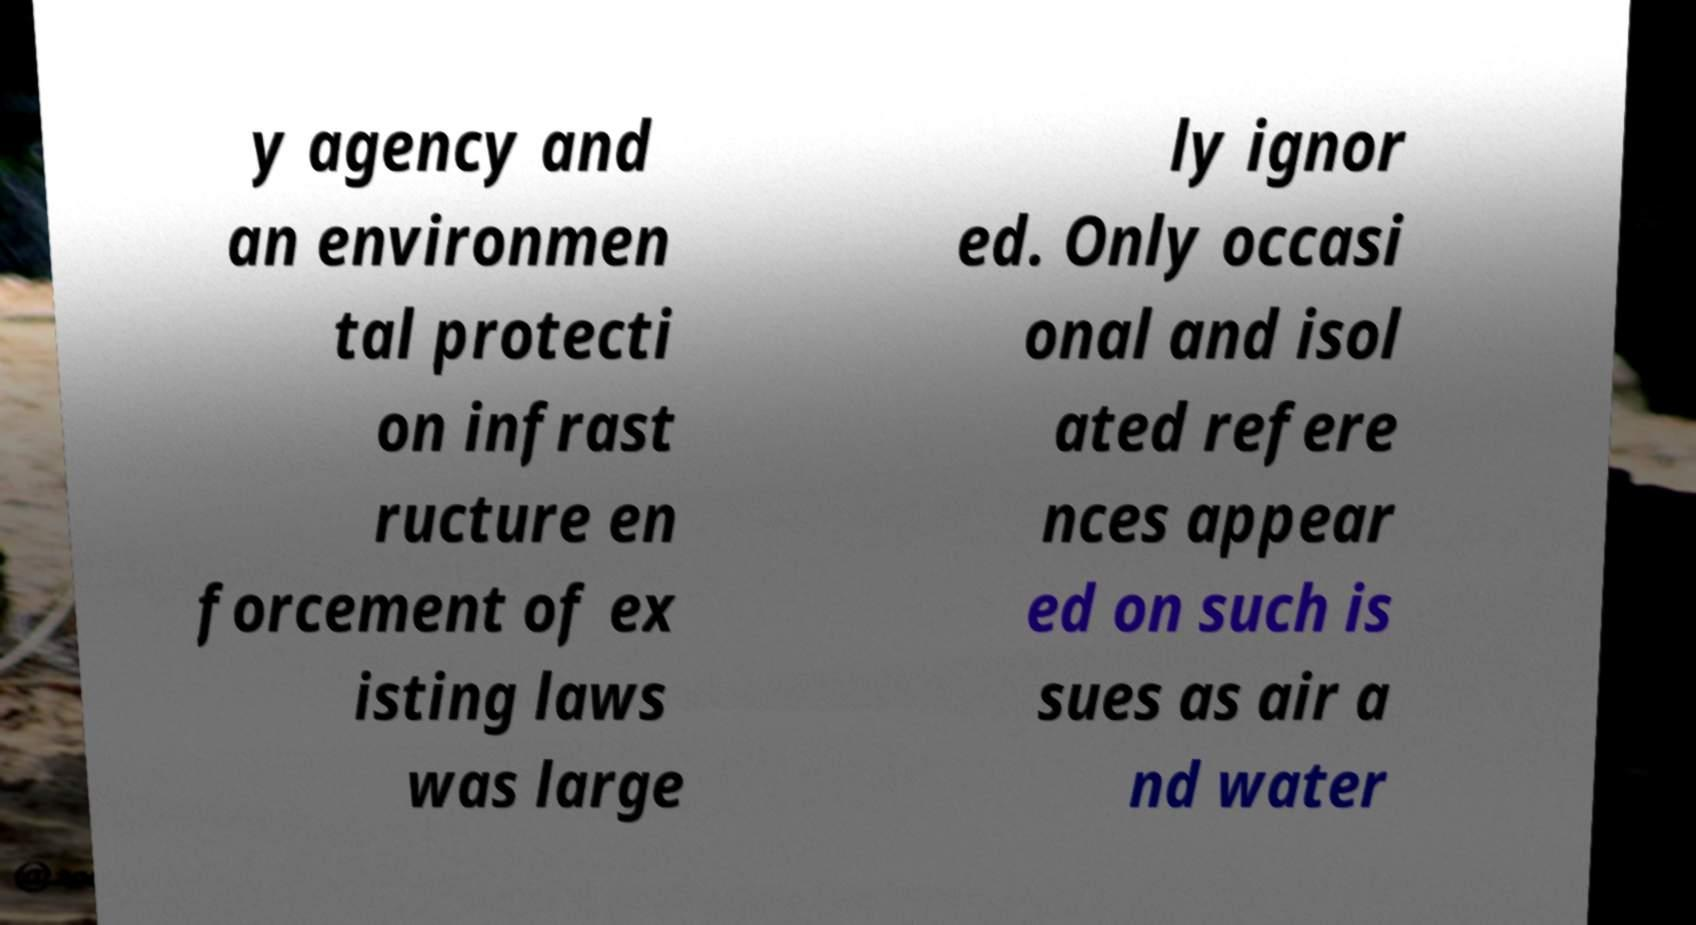For documentation purposes, I need the text within this image transcribed. Could you provide that? y agency and an environmen tal protecti on infrast ructure en forcement of ex isting laws was large ly ignor ed. Only occasi onal and isol ated refere nces appear ed on such is sues as air a nd water 